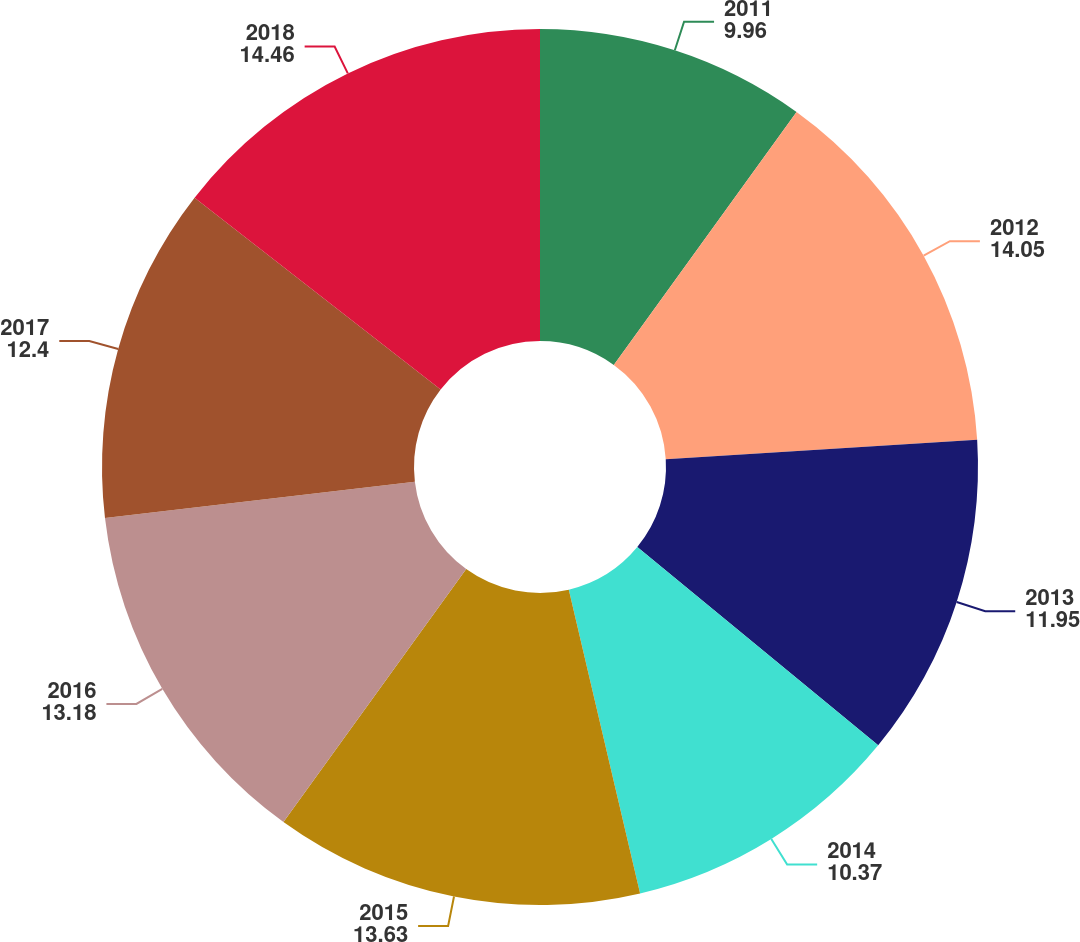Convert chart. <chart><loc_0><loc_0><loc_500><loc_500><pie_chart><fcel>2011<fcel>2012<fcel>2013<fcel>2014<fcel>2015<fcel>2016<fcel>2017<fcel>2018<nl><fcel>9.96%<fcel>14.05%<fcel>11.95%<fcel>10.37%<fcel>13.63%<fcel>13.18%<fcel>12.4%<fcel>14.46%<nl></chart> 